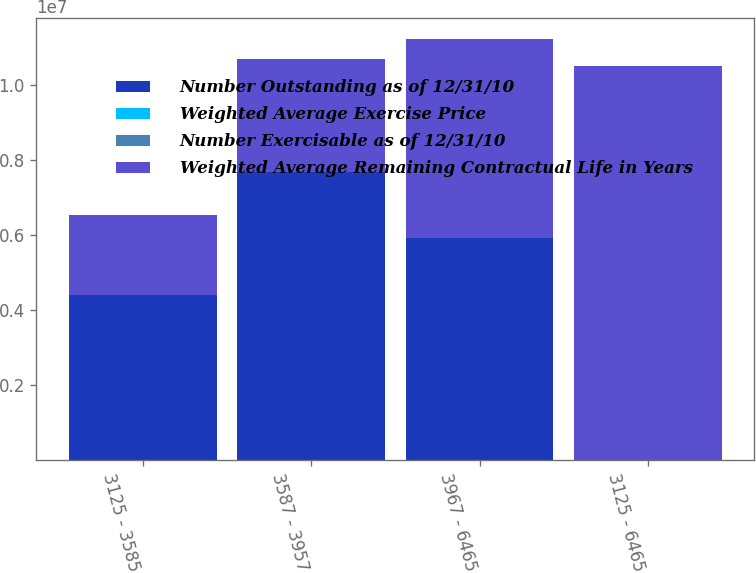<chart> <loc_0><loc_0><loc_500><loc_500><stacked_bar_chart><ecel><fcel>3125 - 3585<fcel>3587 - 3957<fcel>3967 - 6465<fcel>3125 - 6465<nl><fcel>Number Outstanding as of 12/31/10<fcel>4.39726e+06<fcel>7.68188e+06<fcel>5.91794e+06<fcel>54.18<nl><fcel>Weighted Average Exercise Price<fcel>5.9<fcel>7<fcel>5.1<fcel>6.1<nl><fcel>Number Exercisable as of 12/31/10<fcel>34.33<fcel>37.51<fcel>54.18<fcel>42.21<nl><fcel>Weighted Average Remaining Contractual Life in Years<fcel>2.14632e+06<fcel>3.03192e+06<fcel>5.32888e+06<fcel>1.05071e+07<nl></chart> 